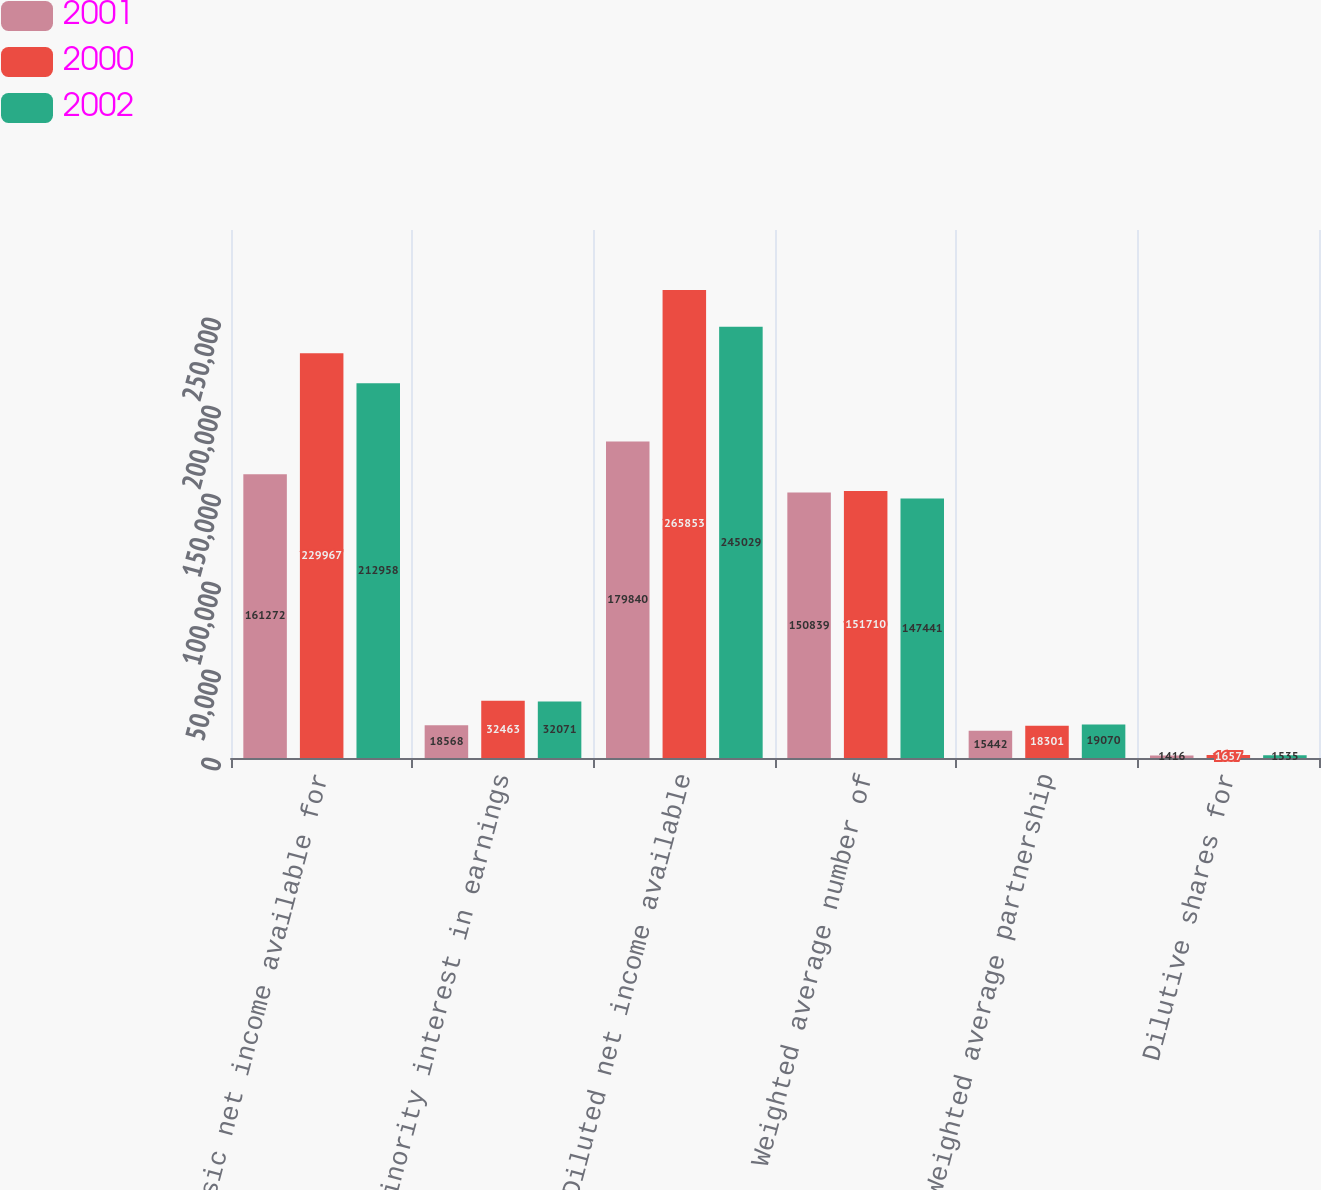Convert chart to OTSL. <chart><loc_0><loc_0><loc_500><loc_500><stacked_bar_chart><ecel><fcel>Basic net income available for<fcel>Minority interest in earnings<fcel>Diluted net income available<fcel>Weighted average number of<fcel>Weighted average partnership<fcel>Dilutive shares for<nl><fcel>2001<fcel>161272<fcel>18568<fcel>179840<fcel>150839<fcel>15442<fcel>1416<nl><fcel>2000<fcel>229967<fcel>32463<fcel>265853<fcel>151710<fcel>18301<fcel>1657<nl><fcel>2002<fcel>212958<fcel>32071<fcel>245029<fcel>147441<fcel>19070<fcel>1535<nl></chart> 